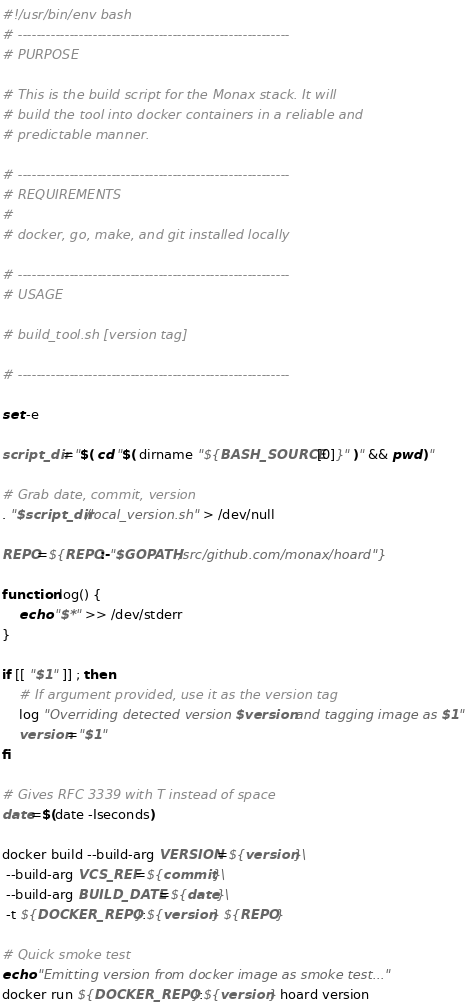<code> <loc_0><loc_0><loc_500><loc_500><_Bash_>#!/usr/bin/env bash
# ----------------------------------------------------------
# PURPOSE

# This is the build script for the Monax stack. It will
# build the tool into docker containers in a reliable and
# predictable manner.

# ----------------------------------------------------------
# REQUIREMENTS
#
# docker, go, make, and git installed locally

# ----------------------------------------------------------
# USAGE

# build_tool.sh [version tag]

# ----------------------------------------------------------

set -e

script_dir="$( cd "$( dirname "${BASH_SOURCE[0]}" )" && pwd )"

# Grab date, commit, version
. "$script_dir/local_version.sh" > /dev/null

REPO=${REPO:-"$GOPATH/src/github.com/monax/hoard"}

function log() {
    echo "$*" >> /dev/stderr
}

if [[ "$1" ]] ; then
    # If argument provided, use it as the version tag
    log "Overriding detected version $version and tagging image as $1"
    version="$1"
fi

# Gives RFC 3339 with T instead of space
date=$(date -Iseconds)

docker build --build-arg VERSION=${version}\
 --build-arg VCS_REF=${commit}\
 --build-arg BUILD_DATE=${date}\
 -t ${DOCKER_REPO}:${version} ${REPO}

# Quick smoke test
echo "Emitting version from docker image as smoke test..."
docker run ${DOCKER_REPO}:${version} hoard version
</code> 